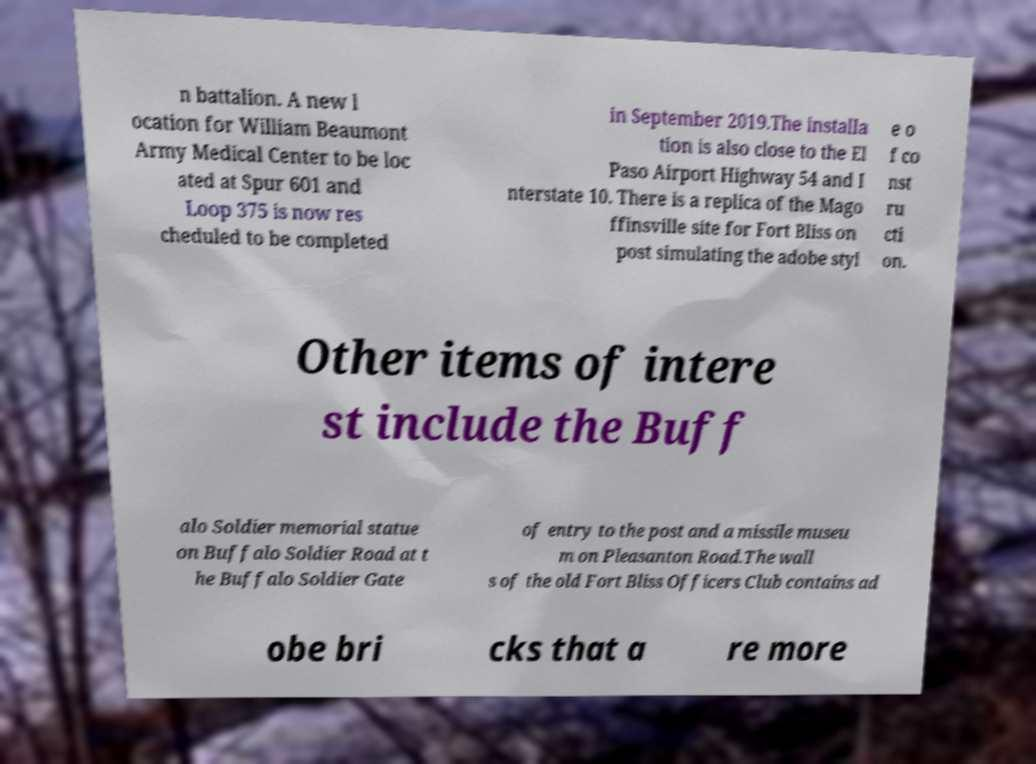For documentation purposes, I need the text within this image transcribed. Could you provide that? n battalion. A new l ocation for William Beaumont Army Medical Center to be loc ated at Spur 601 and Loop 375 is now res cheduled to be completed in September 2019.The installa tion is also close to the El Paso Airport Highway 54 and I nterstate 10. There is a replica of the Mago ffinsville site for Fort Bliss on post simulating the adobe styl e o f co nst ru cti on. Other items of intere st include the Buff alo Soldier memorial statue on Buffalo Soldier Road at t he Buffalo Soldier Gate of entry to the post and a missile museu m on Pleasanton Road.The wall s of the old Fort Bliss Officers Club contains ad obe bri cks that a re more 